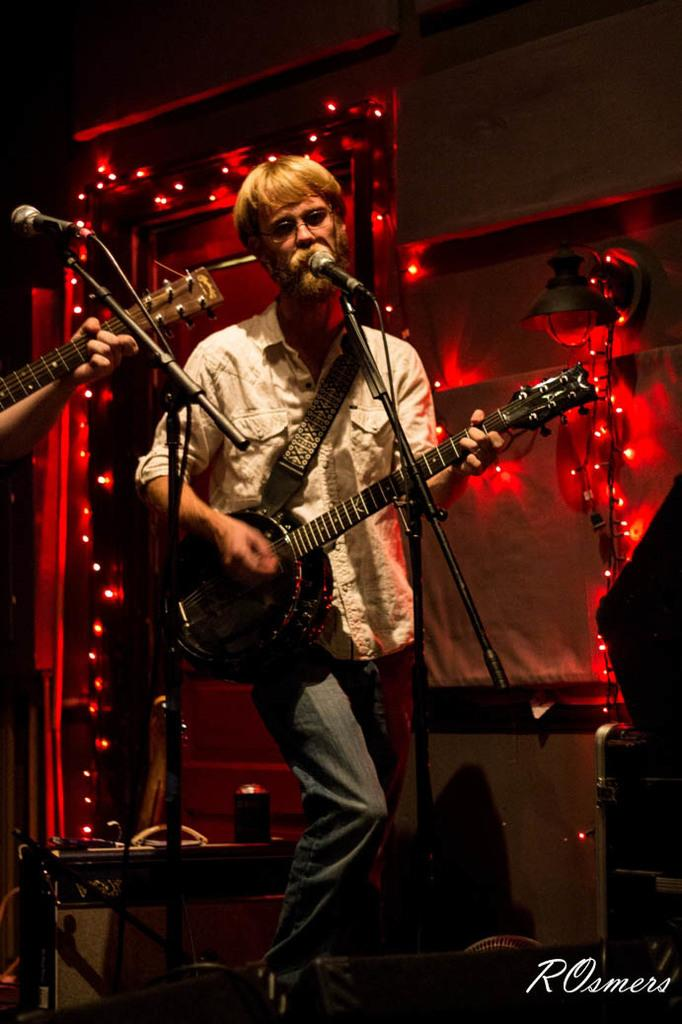What is the person in the image doing with their hands? The person is holding a guitar. What activity is the person engaged in? The person is playing the guitar and singing a song. Can you describe the background of the image? There are lights visible in the background. What type of protest is the person leading in the image? There is no protest present in the image; the person is playing a guitar and singing a song. What is the relation between the person and the home in the image? There is no home present in the image, so it is not possible to determine any relation between the person and a home. 